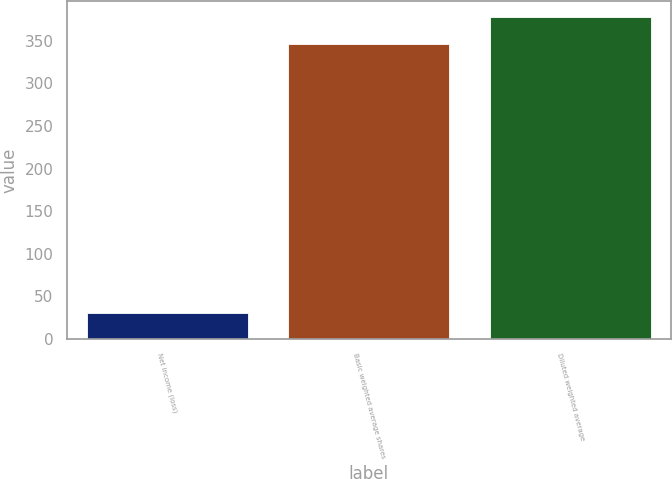Convert chart to OTSL. <chart><loc_0><loc_0><loc_500><loc_500><bar_chart><fcel>Net income (loss)<fcel>Basic weighted average shares<fcel>Diluted weighted average<nl><fcel>31<fcel>346<fcel>377.5<nl></chart> 